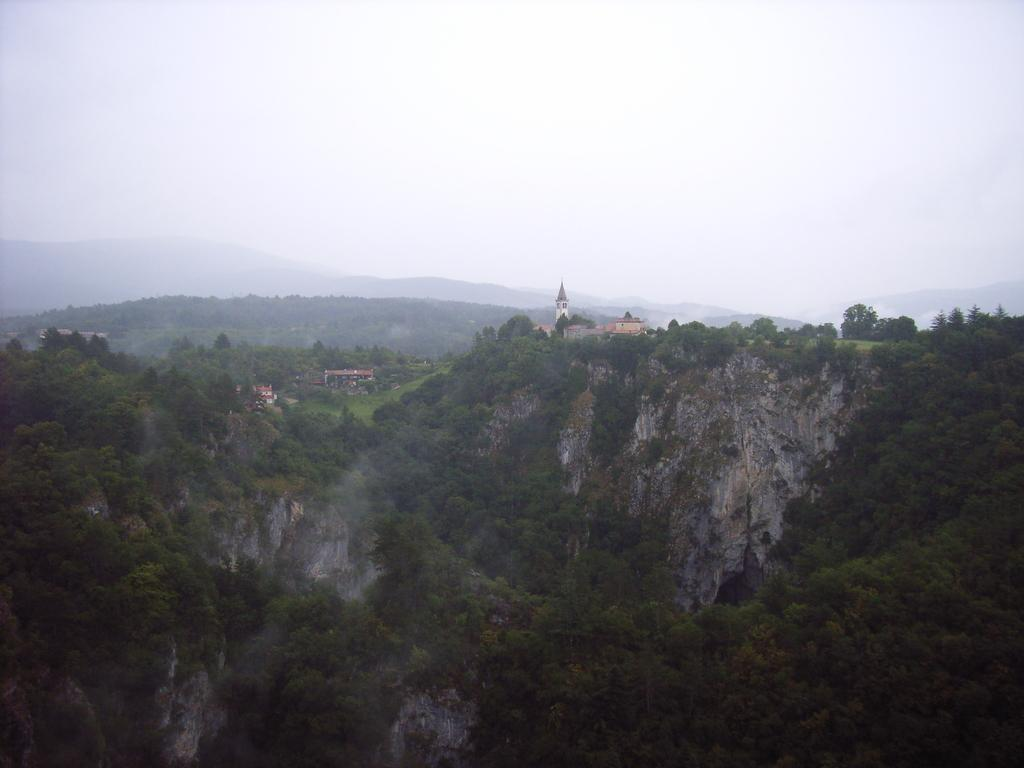What type of natural formation can be seen in the image? There are mountains in the image. What vegetation is present on the mountains? There are trees and grass on the mountains. Are there any man-made structures on the mountains? Yes, there are buildings on the mountains. What is visible at the top of the image? The sky is visible at the top of the image. What type of destruction can be seen on the mountains in the image? There is no destruction visible on the mountains in the image. What type of tool is being used to dig into the mountains in the image? There is no tool or digging activity present in the image. 